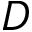Convert formula to latex. <formula><loc_0><loc_0><loc_500><loc_500>D</formula> 